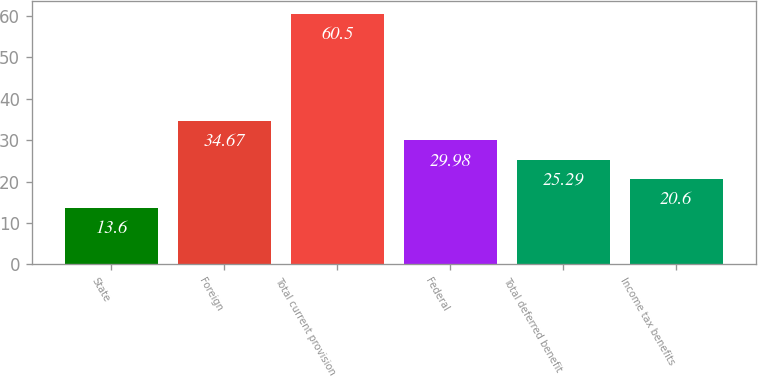Convert chart. <chart><loc_0><loc_0><loc_500><loc_500><bar_chart><fcel>State<fcel>Foreign<fcel>Total current provision<fcel>Federal<fcel>Total deferred benefit<fcel>Income tax benefits<nl><fcel>13.6<fcel>34.67<fcel>60.5<fcel>29.98<fcel>25.29<fcel>20.6<nl></chart> 